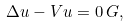Convert formula to latex. <formula><loc_0><loc_0><loc_500><loc_500>\Delta u - V u = 0 \, G ,</formula> 